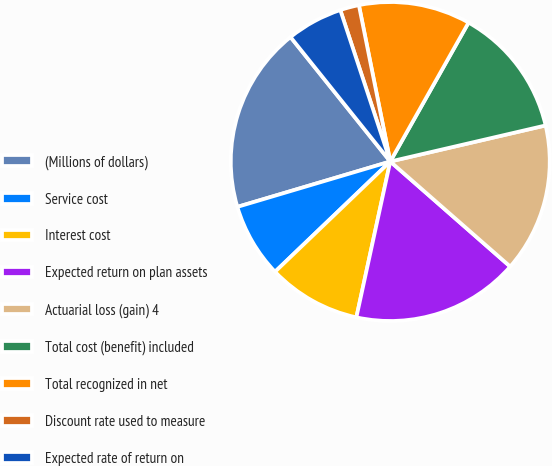<chart> <loc_0><loc_0><loc_500><loc_500><pie_chart><fcel>(Millions of dollars)<fcel>Service cost<fcel>Interest cost<fcel>Expected return on plan assets<fcel>Actuarial loss (gain) 4<fcel>Total cost (benefit) included<fcel>Total recognized in net<fcel>Discount rate used to measure<fcel>Expected rate of return on<nl><fcel>18.84%<fcel>7.56%<fcel>9.44%<fcel>16.96%<fcel>15.08%<fcel>13.2%<fcel>11.32%<fcel>1.92%<fcel>5.68%<nl></chart> 